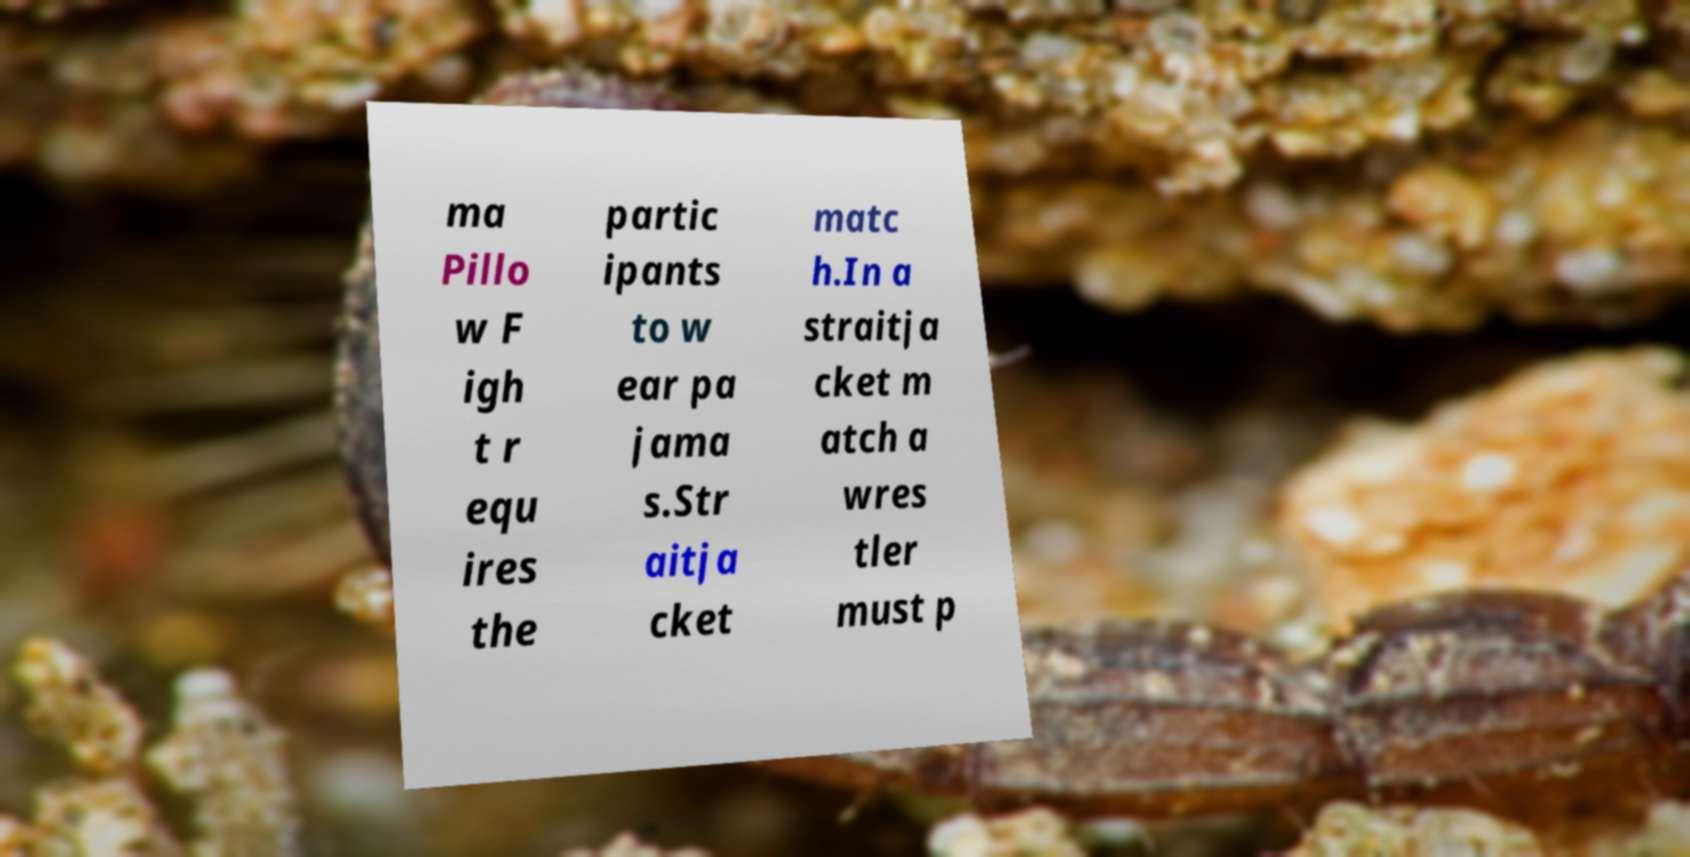Can you accurately transcribe the text from the provided image for me? ma Pillo w F igh t r equ ires the partic ipants to w ear pa jama s.Str aitja cket matc h.In a straitja cket m atch a wres tler must p 